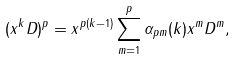<formula> <loc_0><loc_0><loc_500><loc_500>( x ^ { k } D ) ^ { p } = x ^ { p ( k - 1 ) } \sum _ { m = 1 } ^ { p } \alpha _ { p m } ( k ) x ^ { m } D ^ { m } ,</formula> 